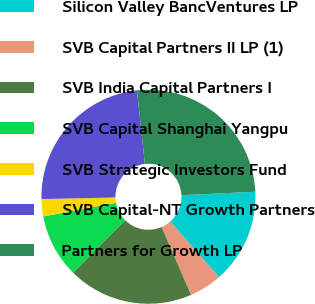<chart> <loc_0><loc_0><loc_500><loc_500><pie_chart><fcel>Silicon Valley BancVentures LP<fcel>SVB Capital Partners II LP (1)<fcel>SVB India Capital Partners I<fcel>SVB Capital Shanghai Yangpu<fcel>SVB Strategic Investors Fund<fcel>SVB Capital-NT Growth Partners<fcel>Partners for Growth LP<nl><fcel>14.29%<fcel>4.94%<fcel>18.96%<fcel>9.61%<fcel>2.6%<fcel>23.64%<fcel>25.97%<nl></chart> 